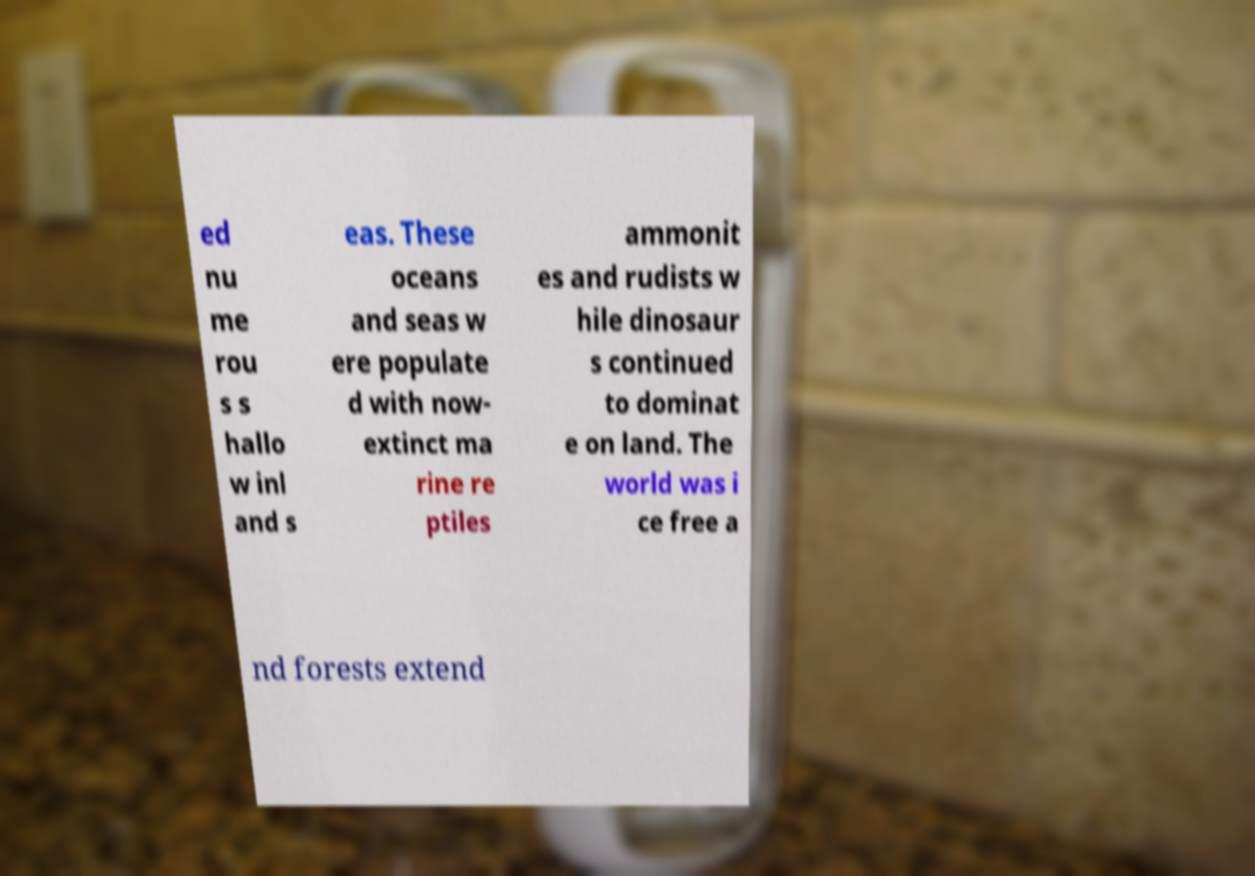Can you accurately transcribe the text from the provided image for me? ed nu me rou s s hallo w inl and s eas. These oceans and seas w ere populate d with now- extinct ma rine re ptiles ammonit es and rudists w hile dinosaur s continued to dominat e on land. The world was i ce free a nd forests extend 